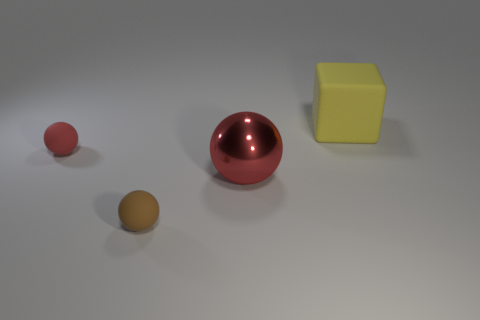Subtract all red matte balls. How many balls are left? 2 Subtract all purple blocks. How many red spheres are left? 2 Add 2 brown spheres. How many objects exist? 6 Subtract 0 brown cylinders. How many objects are left? 4 Subtract all cubes. How many objects are left? 3 Subtract all tiny red rubber objects. Subtract all tiny things. How many objects are left? 1 Add 3 metallic spheres. How many metallic spheres are left? 4 Add 3 blocks. How many blocks exist? 4 